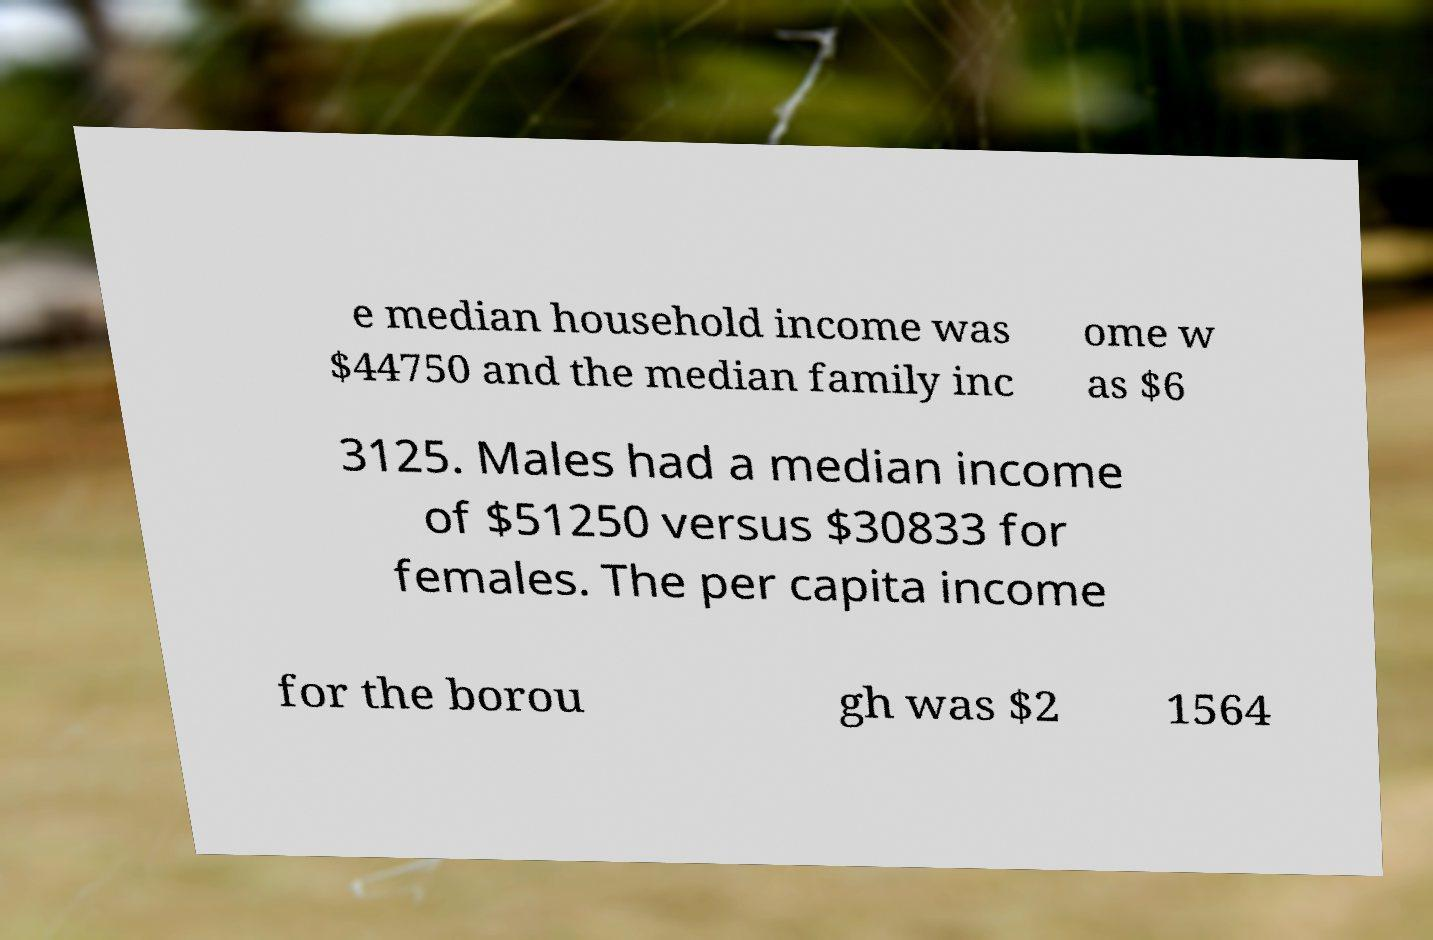For documentation purposes, I need the text within this image transcribed. Could you provide that? e median household income was $44750 and the median family inc ome w as $6 3125. Males had a median income of $51250 versus $30833 for females. The per capita income for the borou gh was $2 1564 